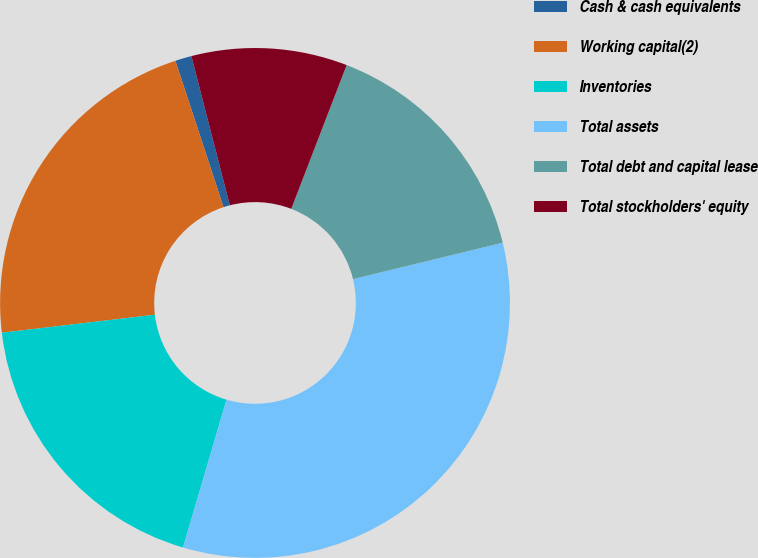Convert chart to OTSL. <chart><loc_0><loc_0><loc_500><loc_500><pie_chart><fcel>Cash & cash equivalents<fcel>Working capital(2)<fcel>Inventories<fcel>Total assets<fcel>Total debt and capital lease<fcel>Total stockholders' equity<nl><fcel>1.04%<fcel>21.81%<fcel>18.58%<fcel>33.36%<fcel>15.35%<fcel>9.87%<nl></chart> 